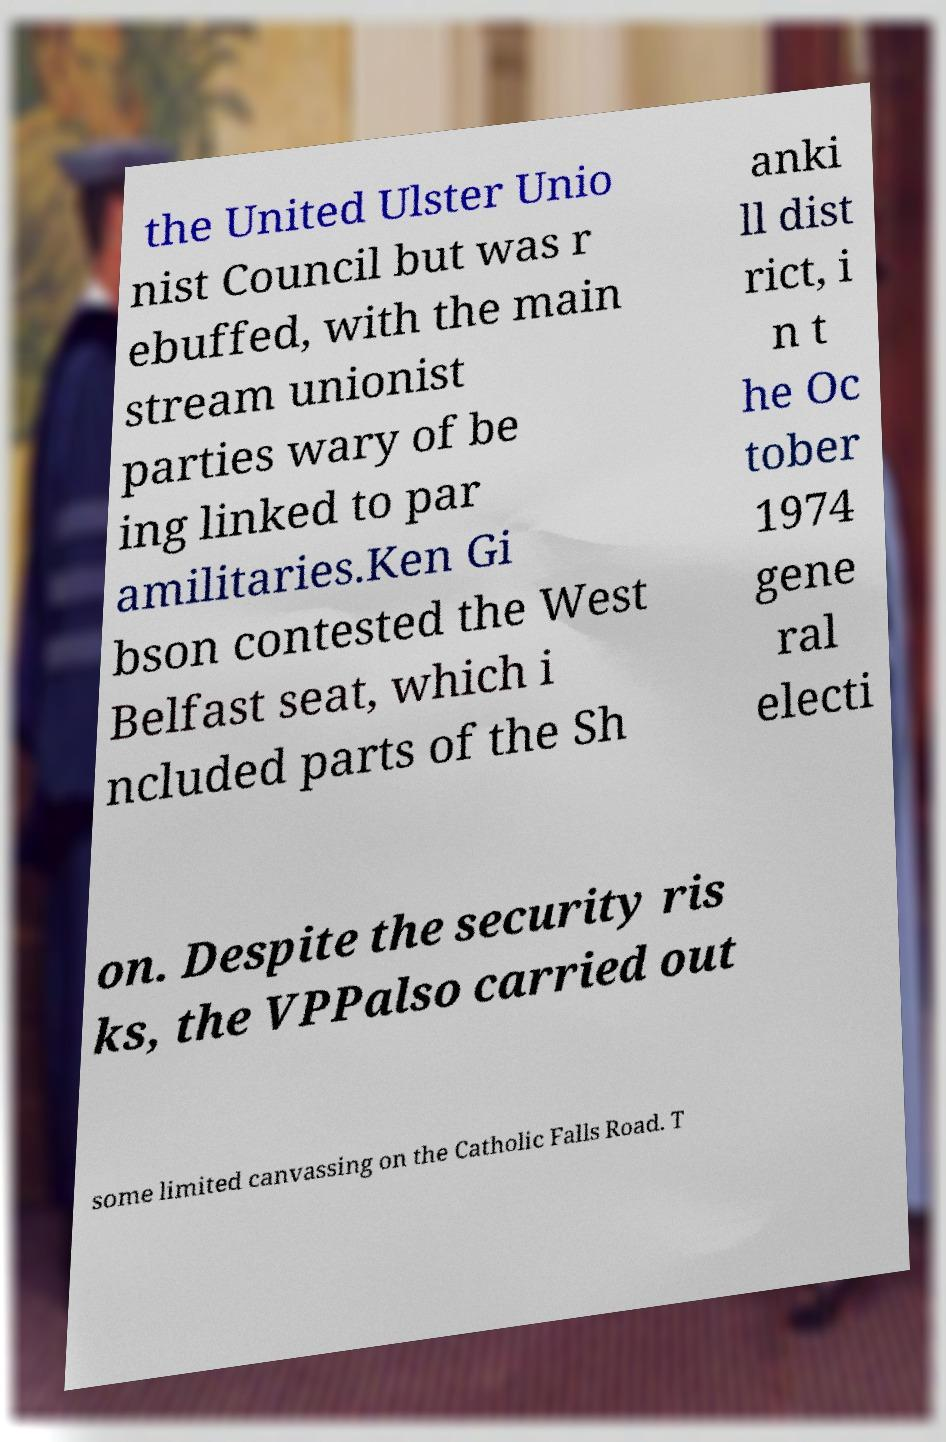Can you read and provide the text displayed in the image?This photo seems to have some interesting text. Can you extract and type it out for me? the United Ulster Unio nist Council but was r ebuffed, with the main stream unionist parties wary of be ing linked to par amilitaries.Ken Gi bson contested the West Belfast seat, which i ncluded parts of the Sh anki ll dist rict, i n t he Oc tober 1974 gene ral electi on. Despite the security ris ks, the VPPalso carried out some limited canvassing on the Catholic Falls Road. T 